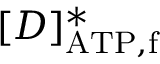Convert formula to latex. <formula><loc_0><loc_0><loc_500><loc_500>[ D ] _ { A T P , f } ^ { \ast }</formula> 